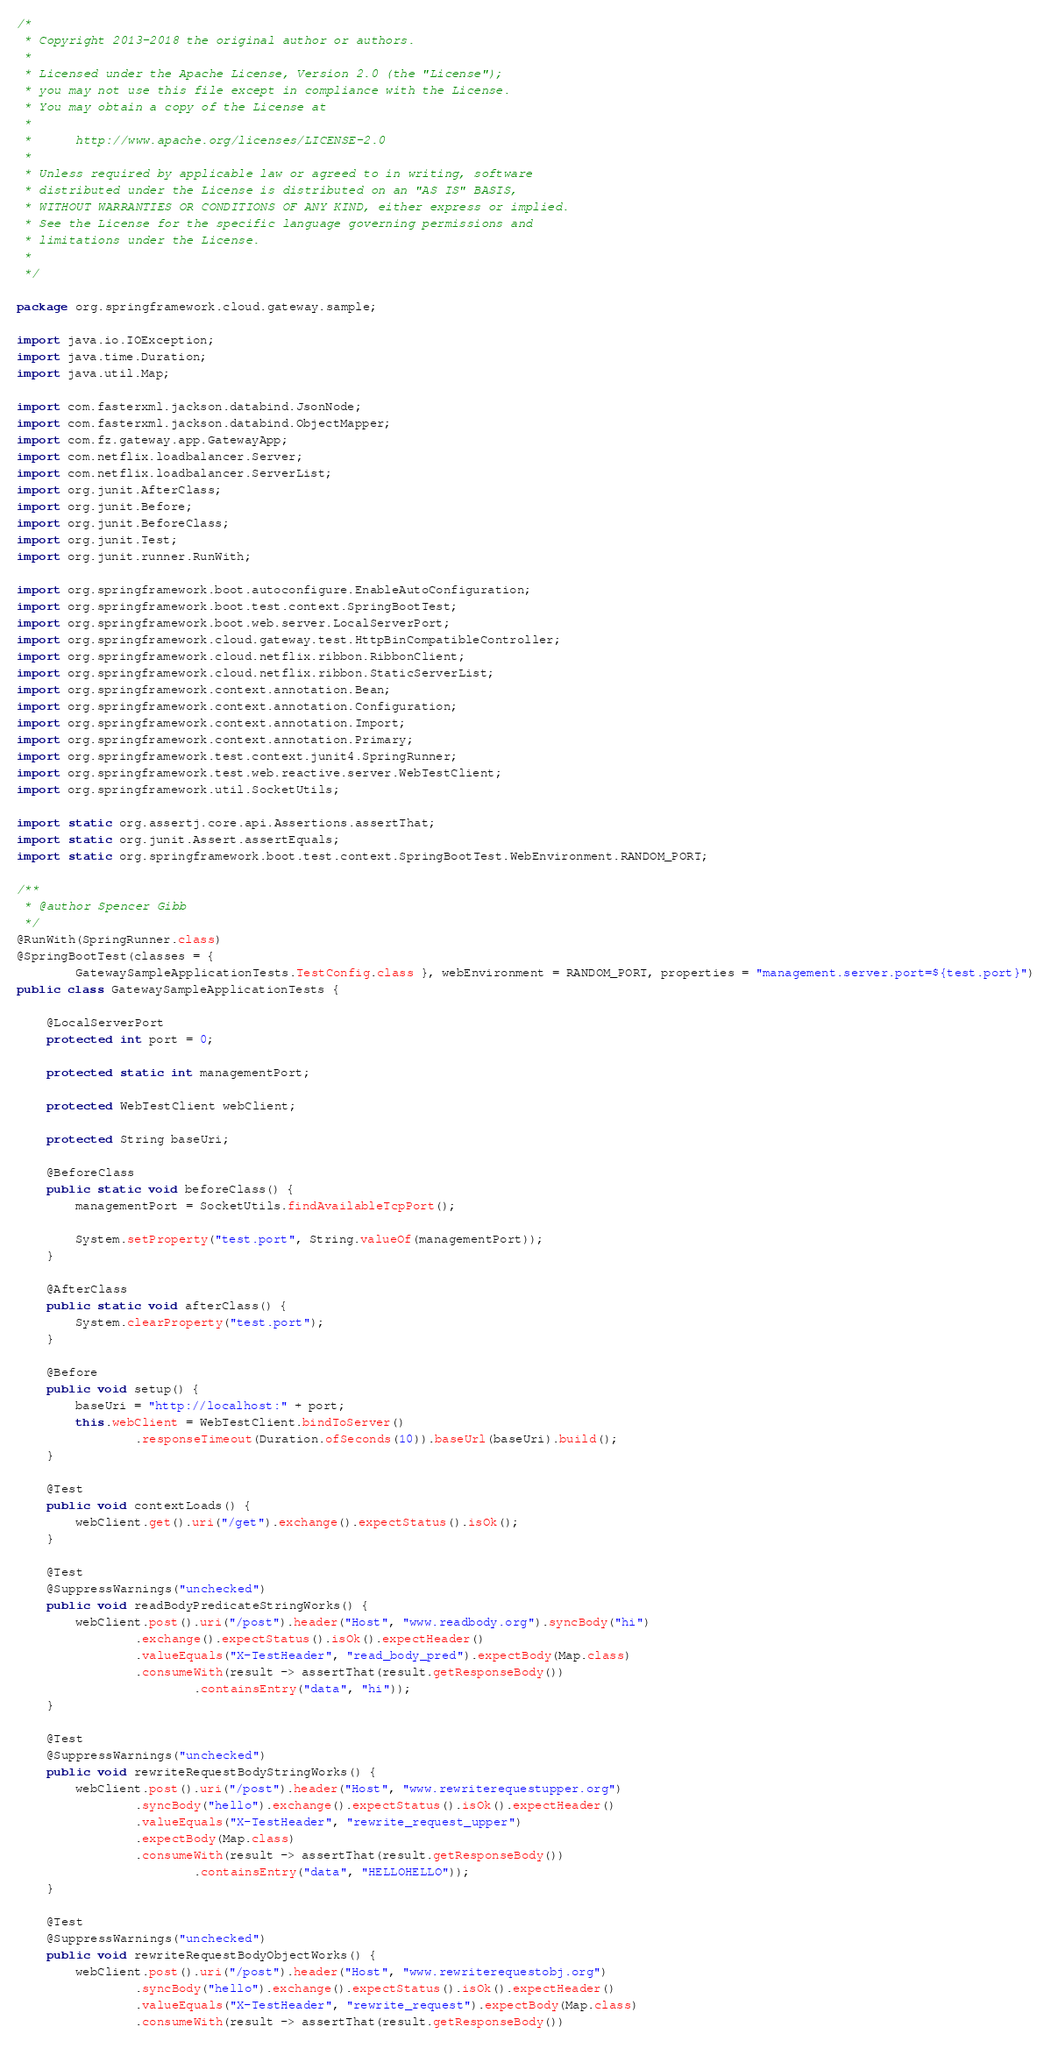<code> <loc_0><loc_0><loc_500><loc_500><_Java_>/*
 * Copyright 2013-2018 the original author or authors.
 *
 * Licensed under the Apache License, Version 2.0 (the "License");
 * you may not use this file except in compliance with the License.
 * You may obtain a copy of the License at
 *
 *      http://www.apache.org/licenses/LICENSE-2.0
 *
 * Unless required by applicable law or agreed to in writing, software
 * distributed under the License is distributed on an "AS IS" BASIS,
 * WITHOUT WARRANTIES OR CONDITIONS OF ANY KIND, either express or implied.
 * See the License for the specific language governing permissions and
 * limitations under the License.
 *
 */

package org.springframework.cloud.gateway.sample;

import java.io.IOException;
import java.time.Duration;
import java.util.Map;

import com.fasterxml.jackson.databind.JsonNode;
import com.fasterxml.jackson.databind.ObjectMapper;
import com.fz.gateway.app.GatewayApp;
import com.netflix.loadbalancer.Server;
import com.netflix.loadbalancer.ServerList;
import org.junit.AfterClass;
import org.junit.Before;
import org.junit.BeforeClass;
import org.junit.Test;
import org.junit.runner.RunWith;

import org.springframework.boot.autoconfigure.EnableAutoConfiguration;
import org.springframework.boot.test.context.SpringBootTest;
import org.springframework.boot.web.server.LocalServerPort;
import org.springframework.cloud.gateway.test.HttpBinCompatibleController;
import org.springframework.cloud.netflix.ribbon.RibbonClient;
import org.springframework.cloud.netflix.ribbon.StaticServerList;
import org.springframework.context.annotation.Bean;
import org.springframework.context.annotation.Configuration;
import org.springframework.context.annotation.Import;
import org.springframework.context.annotation.Primary;
import org.springframework.test.context.junit4.SpringRunner;
import org.springframework.test.web.reactive.server.WebTestClient;
import org.springframework.util.SocketUtils;

import static org.assertj.core.api.Assertions.assertThat;
import static org.junit.Assert.assertEquals;
import static org.springframework.boot.test.context.SpringBootTest.WebEnvironment.RANDOM_PORT;

/**
 * @author Spencer Gibb
 */
@RunWith(SpringRunner.class)
@SpringBootTest(classes = {
		GatewaySampleApplicationTests.TestConfig.class }, webEnvironment = RANDOM_PORT, properties = "management.server.port=${test.port}")
public class GatewaySampleApplicationTests {

	@LocalServerPort
	protected int port = 0;

	protected static int managementPort;

	protected WebTestClient webClient;

	protected String baseUri;

	@BeforeClass
	public static void beforeClass() {
		managementPort = SocketUtils.findAvailableTcpPort();

		System.setProperty("test.port", String.valueOf(managementPort));
	}

	@AfterClass
	public static void afterClass() {
		System.clearProperty("test.port");
	}

	@Before
	public void setup() {
		baseUri = "http://localhost:" + port;
		this.webClient = WebTestClient.bindToServer()
				.responseTimeout(Duration.ofSeconds(10)).baseUrl(baseUri).build();
	}

	@Test
	public void contextLoads() {
		webClient.get().uri("/get").exchange().expectStatus().isOk();
	}

	@Test
	@SuppressWarnings("unchecked")
	public void readBodyPredicateStringWorks() {
		webClient.post().uri("/post").header("Host", "www.readbody.org").syncBody("hi")
				.exchange().expectStatus().isOk().expectHeader()
				.valueEquals("X-TestHeader", "read_body_pred").expectBody(Map.class)
				.consumeWith(result -> assertThat(result.getResponseBody())
						.containsEntry("data", "hi"));
	}

	@Test
	@SuppressWarnings("unchecked")
	public void rewriteRequestBodyStringWorks() {
		webClient.post().uri("/post").header("Host", "www.rewriterequestupper.org")
				.syncBody("hello").exchange().expectStatus().isOk().expectHeader()
				.valueEquals("X-TestHeader", "rewrite_request_upper")
				.expectBody(Map.class)
				.consumeWith(result -> assertThat(result.getResponseBody())
						.containsEntry("data", "HELLOHELLO"));
	}

	@Test
	@SuppressWarnings("unchecked")
	public void rewriteRequestBodyObjectWorks() {
		webClient.post().uri("/post").header("Host", "www.rewriterequestobj.org")
				.syncBody("hello").exchange().expectStatus().isOk().expectHeader()
				.valueEquals("X-TestHeader", "rewrite_request").expectBody(Map.class)
				.consumeWith(result -> assertThat(result.getResponseBody())</code> 